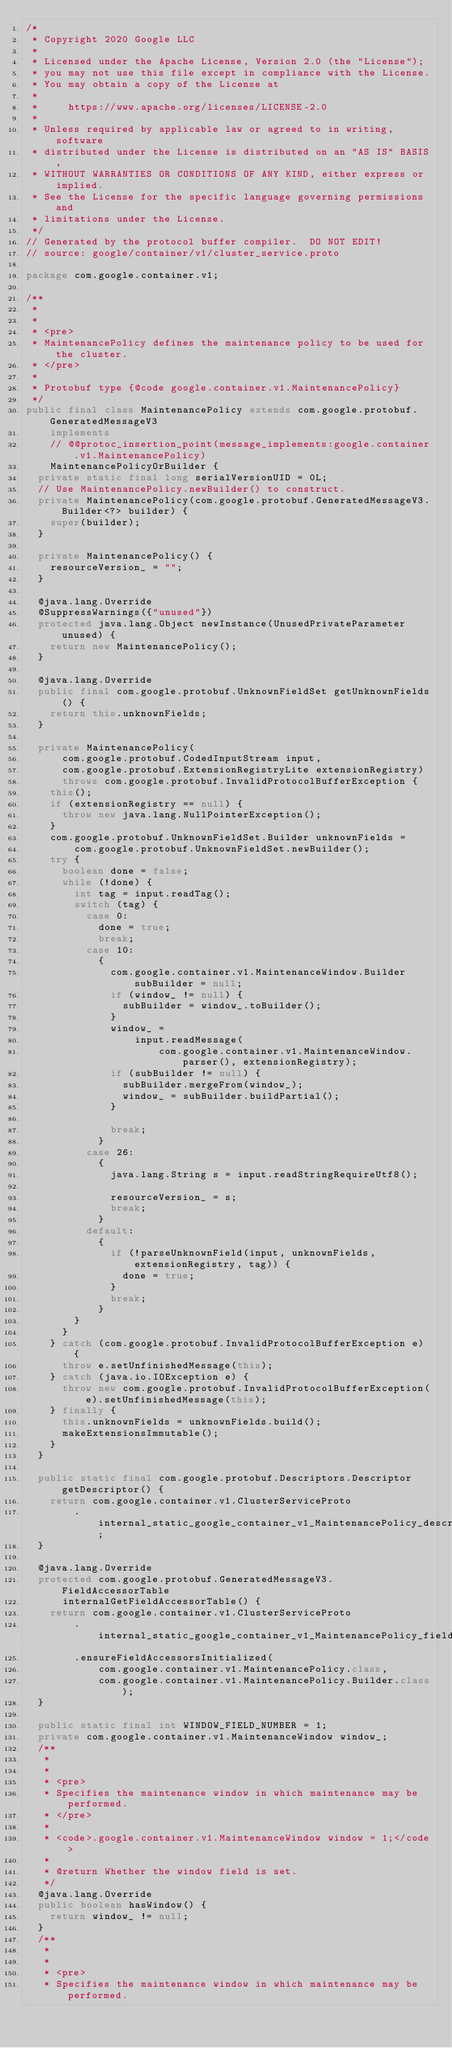Convert code to text. <code><loc_0><loc_0><loc_500><loc_500><_Java_>/*
 * Copyright 2020 Google LLC
 *
 * Licensed under the Apache License, Version 2.0 (the "License");
 * you may not use this file except in compliance with the License.
 * You may obtain a copy of the License at
 *
 *     https://www.apache.org/licenses/LICENSE-2.0
 *
 * Unless required by applicable law or agreed to in writing, software
 * distributed under the License is distributed on an "AS IS" BASIS,
 * WITHOUT WARRANTIES OR CONDITIONS OF ANY KIND, either express or implied.
 * See the License for the specific language governing permissions and
 * limitations under the License.
 */
// Generated by the protocol buffer compiler.  DO NOT EDIT!
// source: google/container/v1/cluster_service.proto

package com.google.container.v1;

/**
 *
 *
 * <pre>
 * MaintenancePolicy defines the maintenance policy to be used for the cluster.
 * </pre>
 *
 * Protobuf type {@code google.container.v1.MaintenancePolicy}
 */
public final class MaintenancePolicy extends com.google.protobuf.GeneratedMessageV3
    implements
    // @@protoc_insertion_point(message_implements:google.container.v1.MaintenancePolicy)
    MaintenancePolicyOrBuilder {
  private static final long serialVersionUID = 0L;
  // Use MaintenancePolicy.newBuilder() to construct.
  private MaintenancePolicy(com.google.protobuf.GeneratedMessageV3.Builder<?> builder) {
    super(builder);
  }

  private MaintenancePolicy() {
    resourceVersion_ = "";
  }

  @java.lang.Override
  @SuppressWarnings({"unused"})
  protected java.lang.Object newInstance(UnusedPrivateParameter unused) {
    return new MaintenancePolicy();
  }

  @java.lang.Override
  public final com.google.protobuf.UnknownFieldSet getUnknownFields() {
    return this.unknownFields;
  }

  private MaintenancePolicy(
      com.google.protobuf.CodedInputStream input,
      com.google.protobuf.ExtensionRegistryLite extensionRegistry)
      throws com.google.protobuf.InvalidProtocolBufferException {
    this();
    if (extensionRegistry == null) {
      throw new java.lang.NullPointerException();
    }
    com.google.protobuf.UnknownFieldSet.Builder unknownFields =
        com.google.protobuf.UnknownFieldSet.newBuilder();
    try {
      boolean done = false;
      while (!done) {
        int tag = input.readTag();
        switch (tag) {
          case 0:
            done = true;
            break;
          case 10:
            {
              com.google.container.v1.MaintenanceWindow.Builder subBuilder = null;
              if (window_ != null) {
                subBuilder = window_.toBuilder();
              }
              window_ =
                  input.readMessage(
                      com.google.container.v1.MaintenanceWindow.parser(), extensionRegistry);
              if (subBuilder != null) {
                subBuilder.mergeFrom(window_);
                window_ = subBuilder.buildPartial();
              }

              break;
            }
          case 26:
            {
              java.lang.String s = input.readStringRequireUtf8();

              resourceVersion_ = s;
              break;
            }
          default:
            {
              if (!parseUnknownField(input, unknownFields, extensionRegistry, tag)) {
                done = true;
              }
              break;
            }
        }
      }
    } catch (com.google.protobuf.InvalidProtocolBufferException e) {
      throw e.setUnfinishedMessage(this);
    } catch (java.io.IOException e) {
      throw new com.google.protobuf.InvalidProtocolBufferException(e).setUnfinishedMessage(this);
    } finally {
      this.unknownFields = unknownFields.build();
      makeExtensionsImmutable();
    }
  }

  public static final com.google.protobuf.Descriptors.Descriptor getDescriptor() {
    return com.google.container.v1.ClusterServiceProto
        .internal_static_google_container_v1_MaintenancePolicy_descriptor;
  }

  @java.lang.Override
  protected com.google.protobuf.GeneratedMessageV3.FieldAccessorTable
      internalGetFieldAccessorTable() {
    return com.google.container.v1.ClusterServiceProto
        .internal_static_google_container_v1_MaintenancePolicy_fieldAccessorTable
        .ensureFieldAccessorsInitialized(
            com.google.container.v1.MaintenancePolicy.class,
            com.google.container.v1.MaintenancePolicy.Builder.class);
  }

  public static final int WINDOW_FIELD_NUMBER = 1;
  private com.google.container.v1.MaintenanceWindow window_;
  /**
   *
   *
   * <pre>
   * Specifies the maintenance window in which maintenance may be performed.
   * </pre>
   *
   * <code>.google.container.v1.MaintenanceWindow window = 1;</code>
   *
   * @return Whether the window field is set.
   */
  @java.lang.Override
  public boolean hasWindow() {
    return window_ != null;
  }
  /**
   *
   *
   * <pre>
   * Specifies the maintenance window in which maintenance may be performed.</code> 